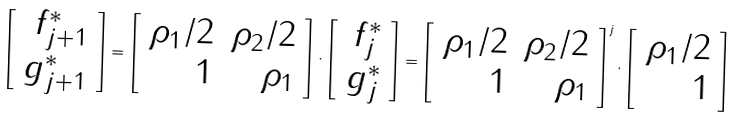<formula> <loc_0><loc_0><loc_500><loc_500>\left [ \begin{array} { r r } f _ { j + 1 } ^ { \ast } \\ g _ { j + 1 } ^ { \ast } \end{array} \right ] = \left [ \begin{array} { r r } \rho _ { 1 } / 2 & \rho _ { 2 } / 2 \\ 1 & \rho _ { 1 } \end{array} \right ] \cdot \left [ \begin{array} { r r } f _ { j } ^ { \ast } \\ g _ { j } ^ { \ast } \end{array} \right ] = \left [ \begin{array} { r r } \rho _ { 1 } / 2 & \rho _ { 2 } / 2 \\ 1 & \rho _ { 1 } \end{array} \right ] ^ { j } \cdot \left [ \begin{array} { r r } \rho _ { 1 } / 2 \\ 1 \end{array} \right ]</formula> 